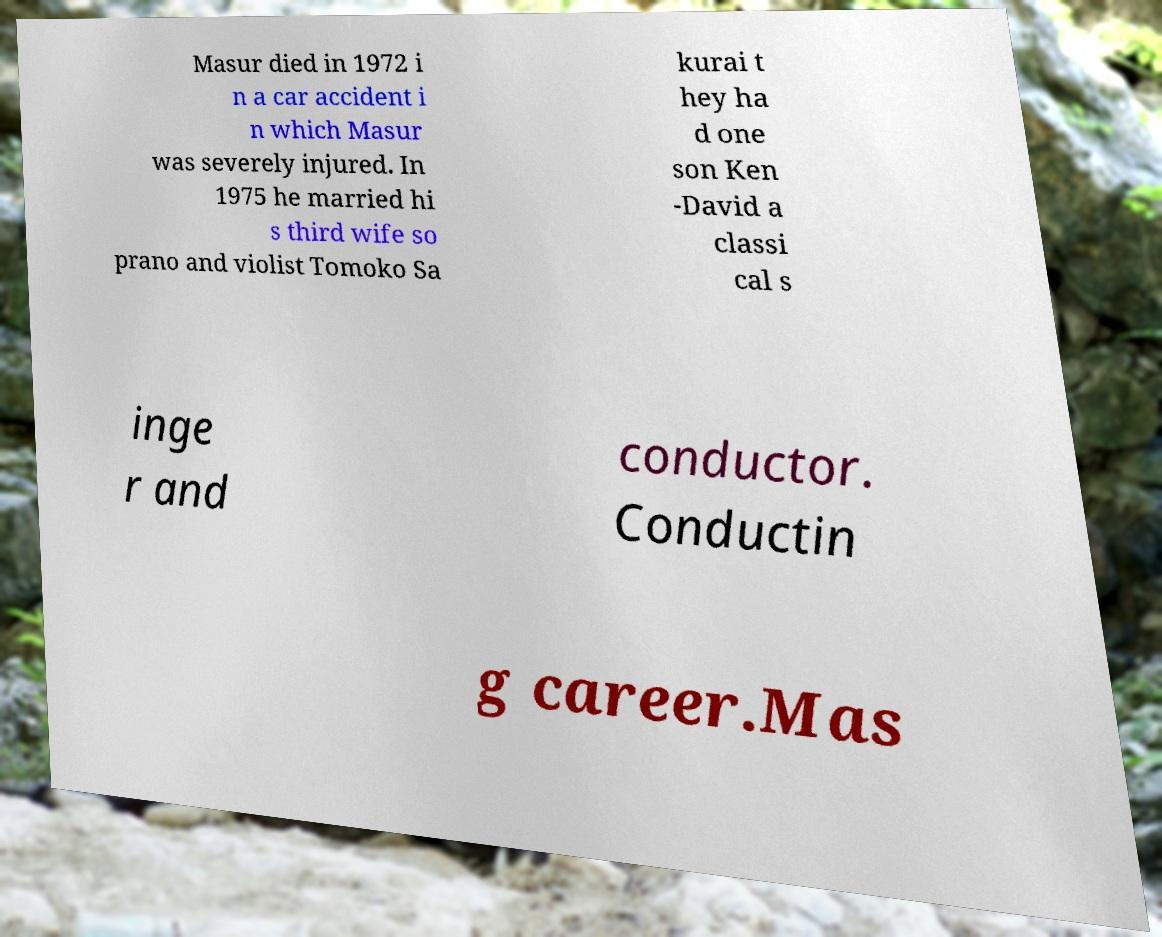I need the written content from this picture converted into text. Can you do that? Masur died in 1972 i n a car accident i n which Masur was severely injured. In 1975 he married hi s third wife so prano and violist Tomoko Sa kurai t hey ha d one son Ken -David a classi cal s inge r and conductor. Conductin g career.Mas 